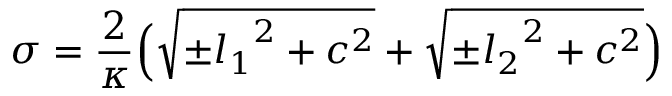Convert formula to latex. <formula><loc_0><loc_0><loc_500><loc_500>\sigma = \frac { 2 } { \kappa } \left ( { \sqrt { { \pm } { l _ { 1 } } ^ { 2 } + c ^ { 2 } } } + { \sqrt { { \pm } { l _ { 2 } } ^ { 2 } + c ^ { 2 } } } \right )</formula> 